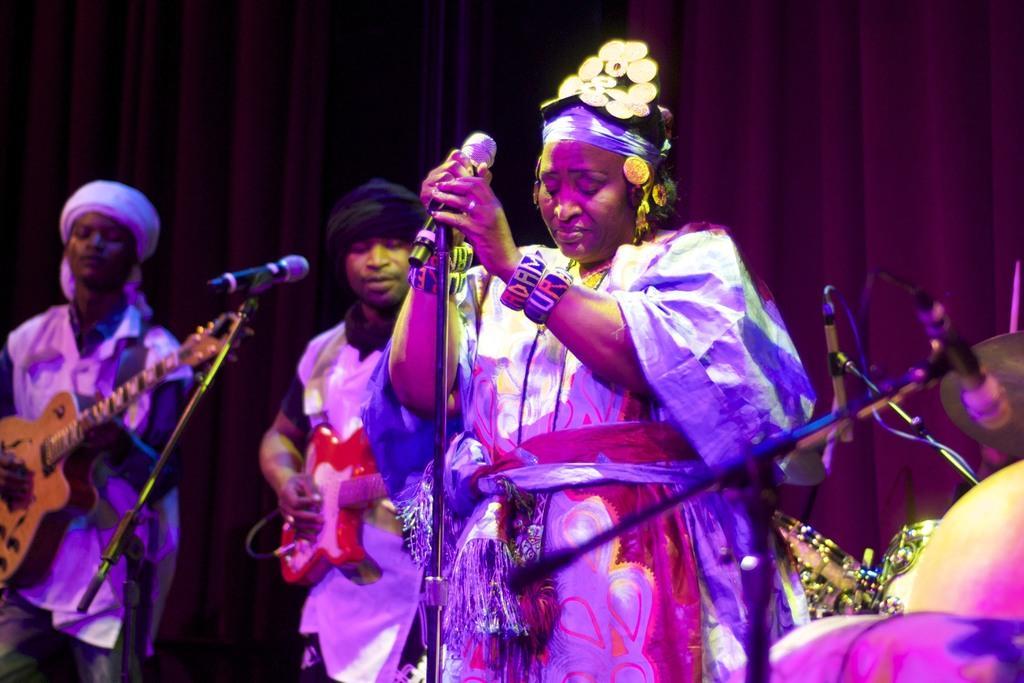Can you describe this image briefly? This image is clicked in a concert. There are three persons in this image. In the front, the woman is standing near the mic stand and holding the mic. In the middle the is playing red color guitar. To the left, the man is playing guitar. To the right, there is a band setup. In the background, there is a brown curtain. 